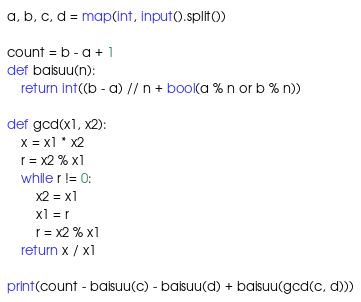Convert code to text. <code><loc_0><loc_0><loc_500><loc_500><_Python_>a, b, c, d = map(int, input().split())

count = b - a + 1
def baisuu(n):
    return int((b - a) // n + bool(a % n or b % n))

def gcd(x1, x2):
    x = x1 * x2
    r = x2 % x1
    while r != 0:
        x2 = x1
        x1 = r
        r = x2 % x1
    return x / x1

print(count - baisuu(c) - baisuu(d) + baisuu(gcd(c, d)))
</code> 